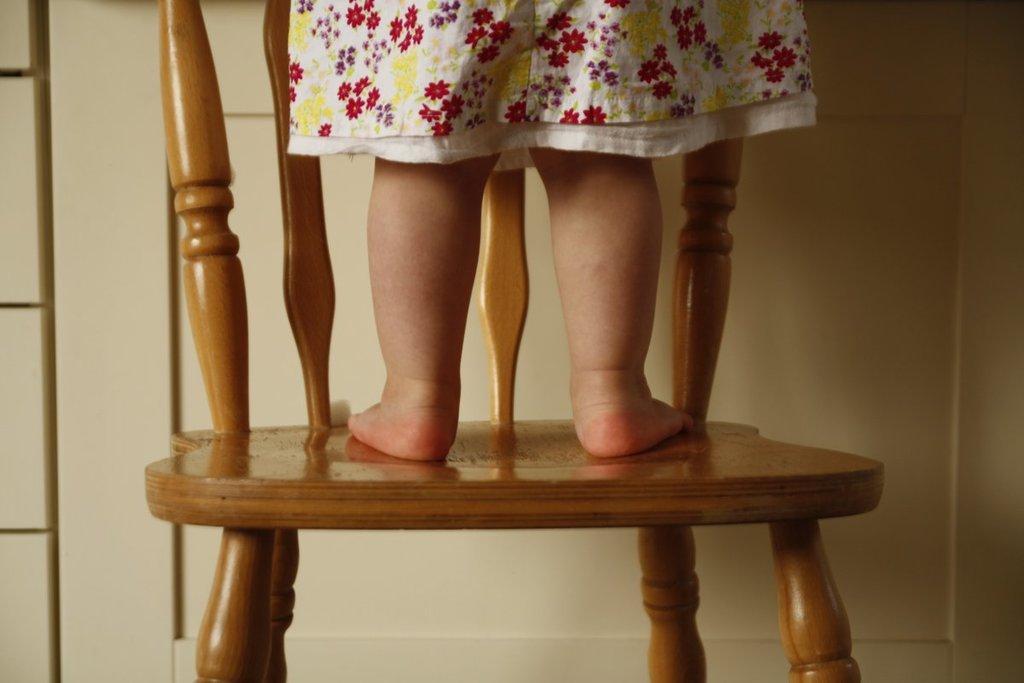How would you summarize this image in a sentence or two? In this image there is a girl standing in a chair, at the back ground there is a cupboard or door. 